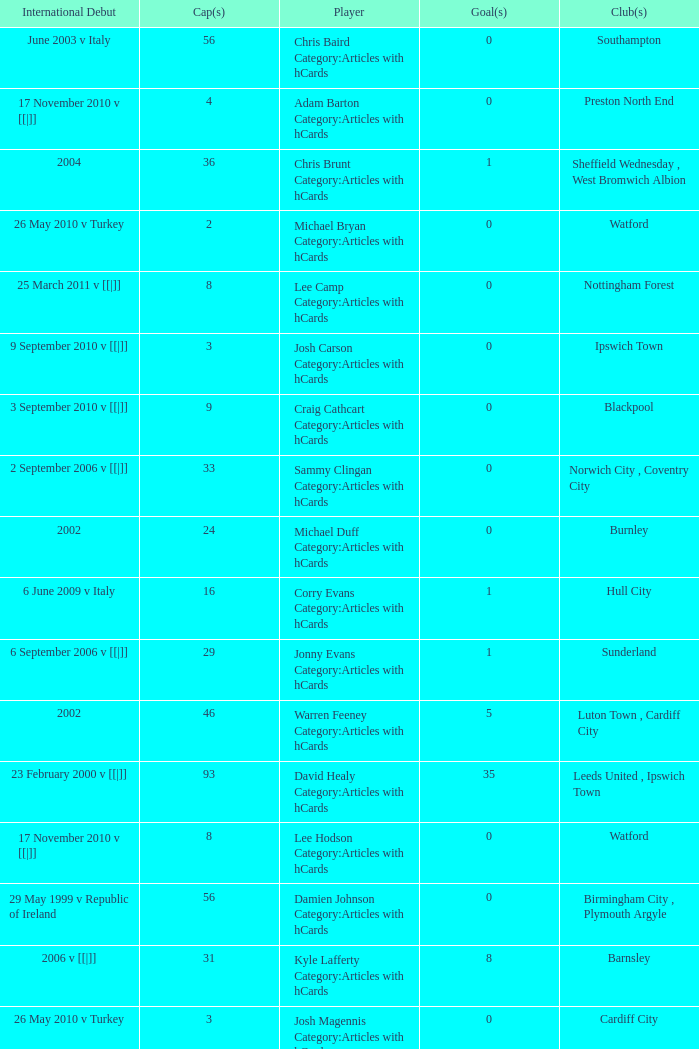How many players had 8 goals? 1.0. 